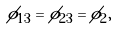<formula> <loc_0><loc_0><loc_500><loc_500>\phi _ { 1 3 } = \phi _ { 2 3 } = \phi _ { 2 } ,</formula> 